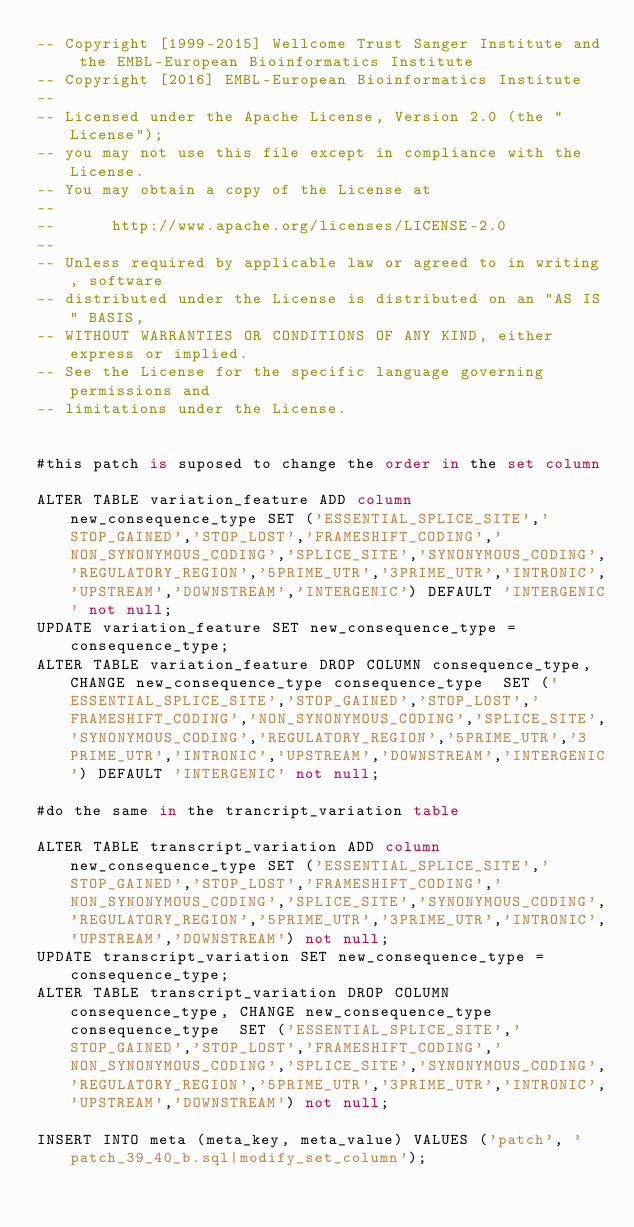Convert code to text. <code><loc_0><loc_0><loc_500><loc_500><_SQL_>-- Copyright [1999-2015] Wellcome Trust Sanger Institute and the EMBL-European Bioinformatics Institute
-- Copyright [2016] EMBL-European Bioinformatics Institute
-- 
-- Licensed under the Apache License, Version 2.0 (the "License");
-- you may not use this file except in compliance with the License.
-- You may obtain a copy of the License at
-- 
--      http://www.apache.org/licenses/LICENSE-2.0
-- 
-- Unless required by applicable law or agreed to in writing, software
-- distributed under the License is distributed on an "AS IS" BASIS,
-- WITHOUT WARRANTIES OR CONDITIONS OF ANY KIND, either express or implied.
-- See the License for the specific language governing permissions and
-- limitations under the License.


#this patch is suposed to change the order in the set column

ALTER TABLE variation_feature ADD column new_consequence_type SET ('ESSENTIAL_SPLICE_SITE','STOP_GAINED','STOP_LOST','FRAMESHIFT_CODING','NON_SYNONYMOUS_CODING','SPLICE_SITE','SYNONYMOUS_CODING','REGULATORY_REGION','5PRIME_UTR','3PRIME_UTR','INTRONIC','UPSTREAM','DOWNSTREAM','INTERGENIC') DEFAULT 'INTERGENIC' not null;
UPDATE variation_feature SET new_consequence_type = consequence_type;
ALTER TABLE variation_feature DROP COLUMN consequence_type, CHANGE new_consequence_type consequence_type  SET ('ESSENTIAL_SPLICE_SITE','STOP_GAINED','STOP_LOST','FRAMESHIFT_CODING','NON_SYNONYMOUS_CODING','SPLICE_SITE','SYNONYMOUS_CODING','REGULATORY_REGION','5PRIME_UTR','3PRIME_UTR','INTRONIC','UPSTREAM','DOWNSTREAM','INTERGENIC') DEFAULT 'INTERGENIC' not null;

#do the same in the trancript_variation table

ALTER TABLE transcript_variation ADD column new_consequence_type SET ('ESSENTIAL_SPLICE_SITE','STOP_GAINED','STOP_LOST','FRAMESHIFT_CODING','NON_SYNONYMOUS_CODING','SPLICE_SITE','SYNONYMOUS_CODING','REGULATORY_REGION','5PRIME_UTR','3PRIME_UTR','INTRONIC','UPSTREAM','DOWNSTREAM') not null;
UPDATE transcript_variation SET new_consequence_type = consequence_type;
ALTER TABLE transcript_variation DROP COLUMN consequence_type, CHANGE new_consequence_type consequence_type  SET ('ESSENTIAL_SPLICE_SITE','STOP_GAINED','STOP_LOST','FRAMESHIFT_CODING','NON_SYNONYMOUS_CODING','SPLICE_SITE','SYNONYMOUS_CODING','REGULATORY_REGION','5PRIME_UTR','3PRIME_UTR','INTRONIC','UPSTREAM','DOWNSTREAM') not null;

INSERT INTO meta (meta_key, meta_value) VALUES ('patch', 'patch_39_40_b.sql|modify_set_column');
</code> 